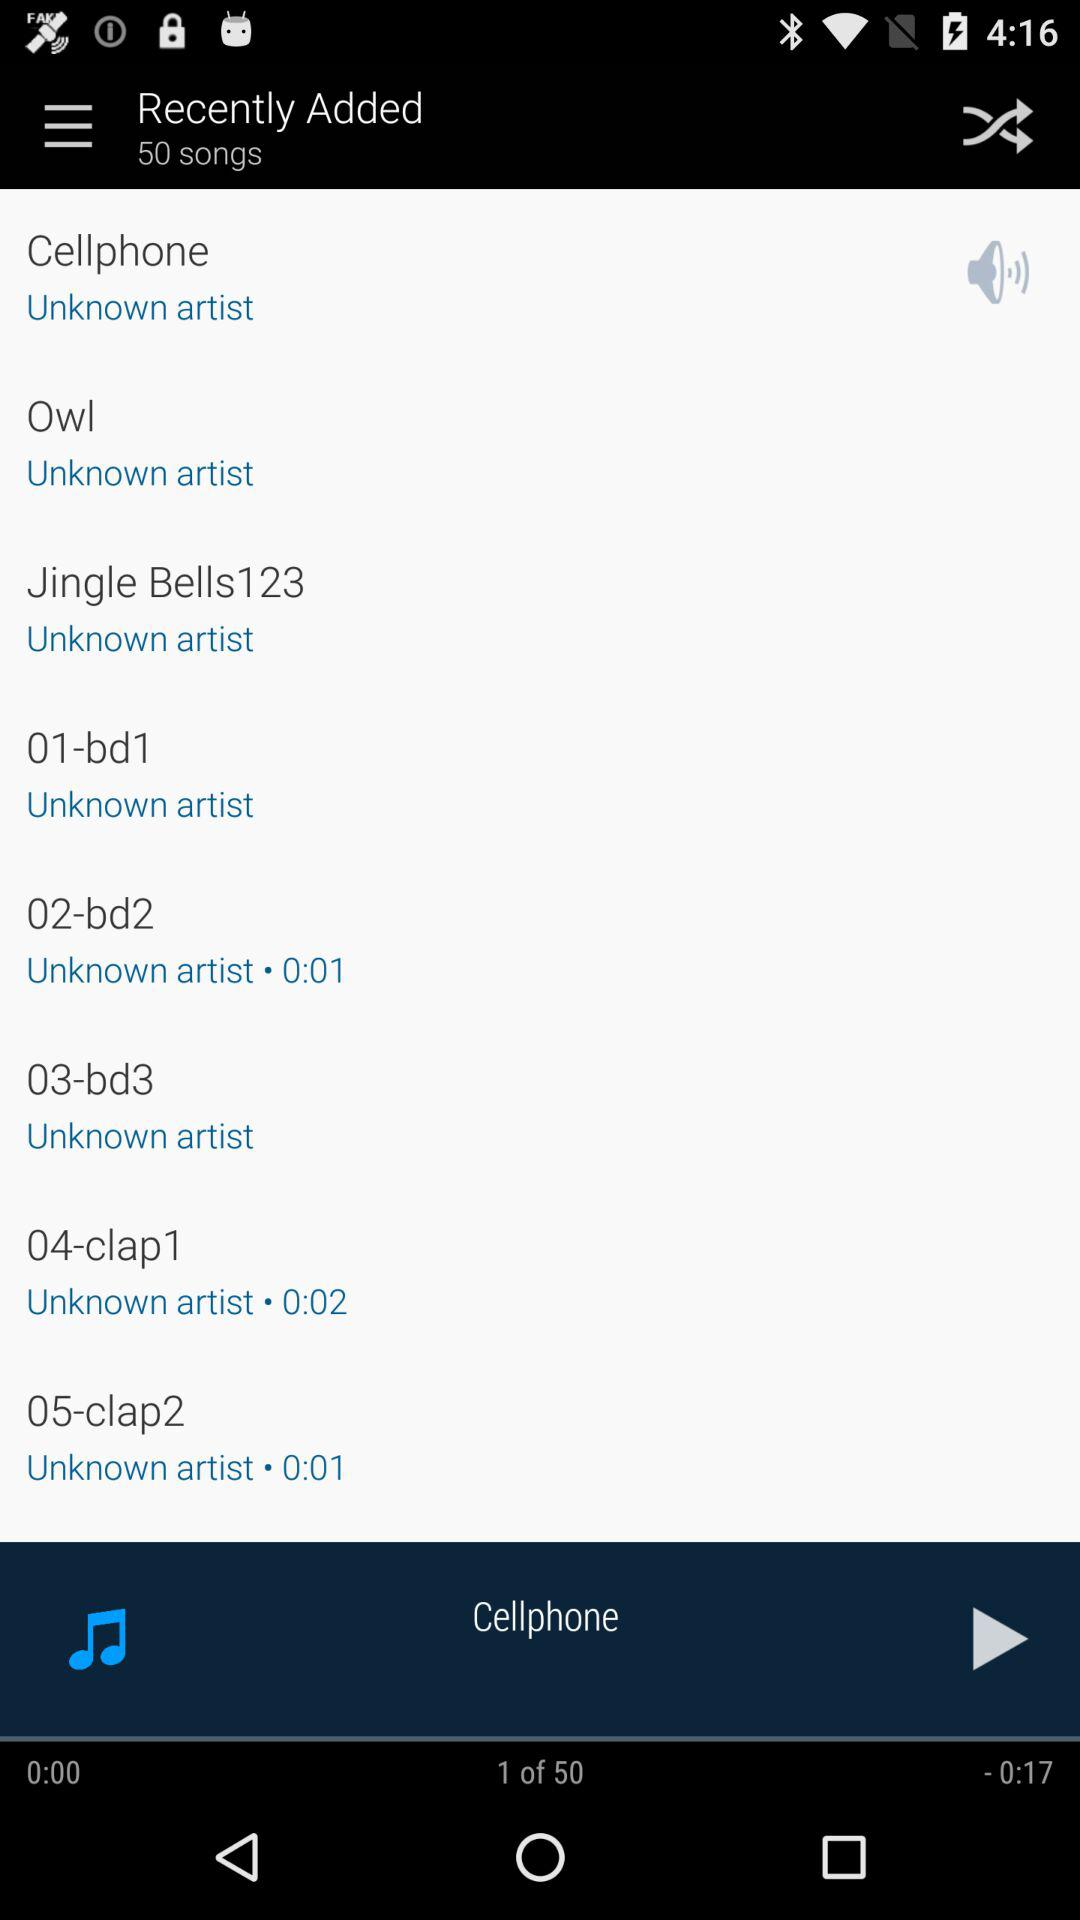Which song was last played? The last played song was "Cellphone". 